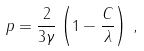Convert formula to latex. <formula><loc_0><loc_0><loc_500><loc_500>p = \frac { 2 } { 3 \gamma } \left ( 1 - \frac { C } { \lambda } \right ) \, ,</formula> 